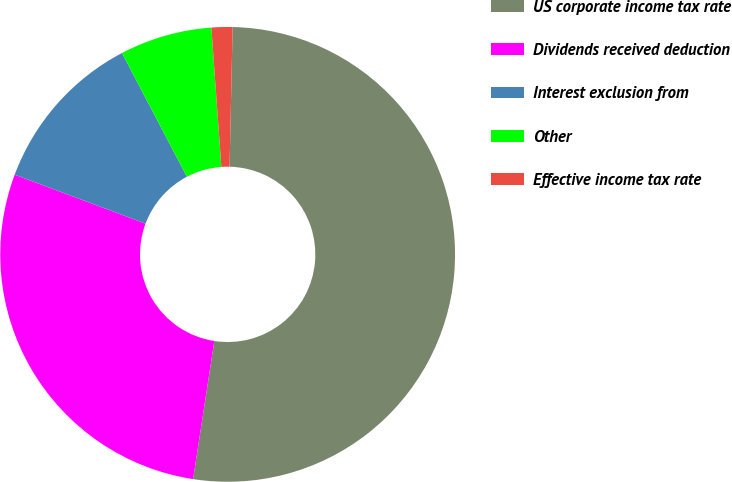Convert chart. <chart><loc_0><loc_0><loc_500><loc_500><pie_chart><fcel>US corporate income tax rate<fcel>Dividends received deduction<fcel>Interest exclusion from<fcel>Other<fcel>Effective income tax rate<nl><fcel>52.08%<fcel>28.27%<fcel>11.61%<fcel>6.55%<fcel>1.49%<nl></chart> 